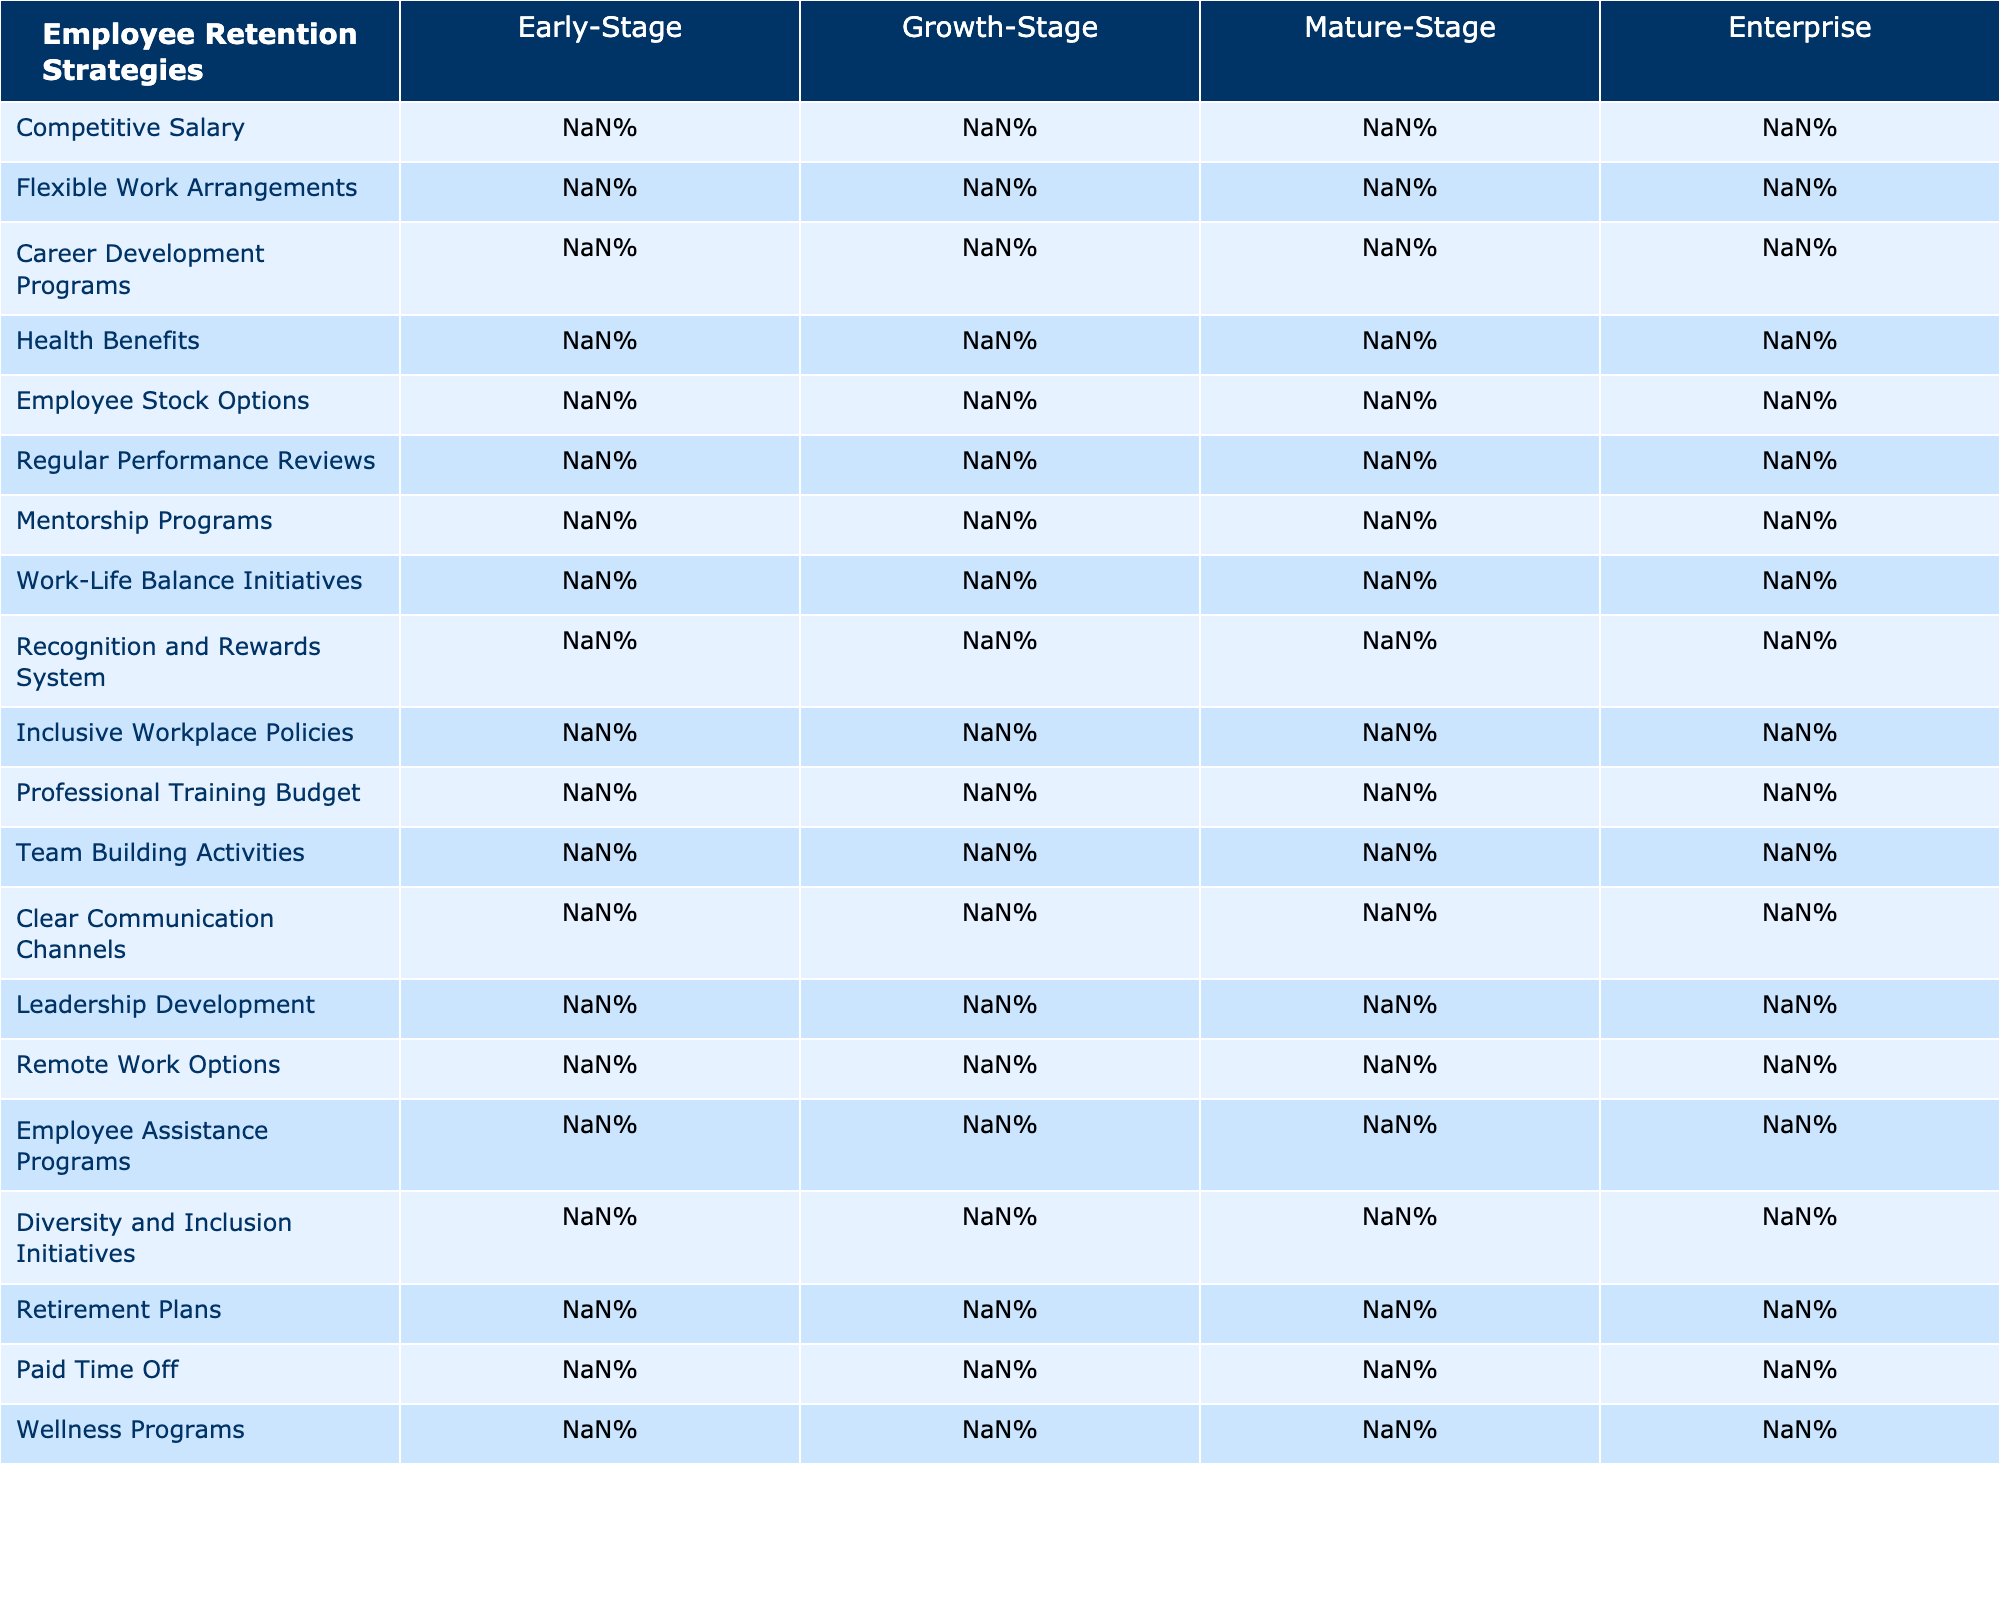What is the competitive salary percentage for Early-Stage companies? The table lists the competitive salary percentage for each company stage. For Early-Stage companies, it shows 85%.
Answer: 85% Which company stage has the highest percentage for Health Benefits? The data indicates various percentages for Health Benefits across company stages. By comparing, we see that Enterprise has the highest at 95%.
Answer: 95% What is the average percentage of Flexible Work Arrangements across all company stages? To find the average, we add the percentages for each stage: (70 + 80 + 85 + 90) = 325. There are 4 stages, so we divide 325 by 4, resulting in 81.25%.
Answer: 81.25% Is there a higher percentage of Employee Stock Options in the Early-Stage or Growth-Stage? The Early-Stage percentage for Employee Stock Options is 50%, while the Growth-Stage percentage is 60%. Since 60% is greater, the Growth-Stage has a higher percentage.
Answer: Yes Which company stage shows a significant increase in Career Development Programs compared to Early-Stage? The percentages for Career Development Programs are 40% (Early-Stage), 65% (Growth-Stage), and 80% (Mature-Stage). The biggest increase occurs from Early-Stage to Mature-Stage, increasing by 40% (from 40% to 80%).
Answer: 40% increase How many Employee Retention Strategies have more than 80% in the Enterprise stage? In the Enterprise stage, we count the percentages over 80%, which are: 85%, 90%, 90%, 95%, and 98%. This gives us a total of 5 strategies.
Answer: 5 What percentage of companies in the Mature-Stage have Leadership Development programs? The table shows that the Lifespan for Leadership Development in the Mature-Stage is at 60%.
Answer: 60% Which two employee retention strategies have the largest disparity between Early-Stage and Enterprise stages? We look at the differences: Competitive Salary (98%-85% = 13%), Flexible Work Arrangements (90%-70% = 20%), and Career Development Programs (90%-40% = 50%). The largest disparity is in Career Development Programs with a difference of 50%.
Answer: Career Development Programs What is the percentage for Recognition and Rewards System in the Growth-Stage? Referring to the table, the percentage for Recognition and Rewards System in the Growth-Stage is 60%.
Answer: 60% Are the percentages for Team Building Activities higher in the Growth-Stage or Mature-Stage? The Team Building Activities percentages are 60% (Growth-Stage) and 70% (Mature-Stage). Comparing these, 70% is higher for the Mature-Stage.
Answer: Mature-Stage has higher percentages 